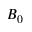<formula> <loc_0><loc_0><loc_500><loc_500>B _ { 0 }</formula> 